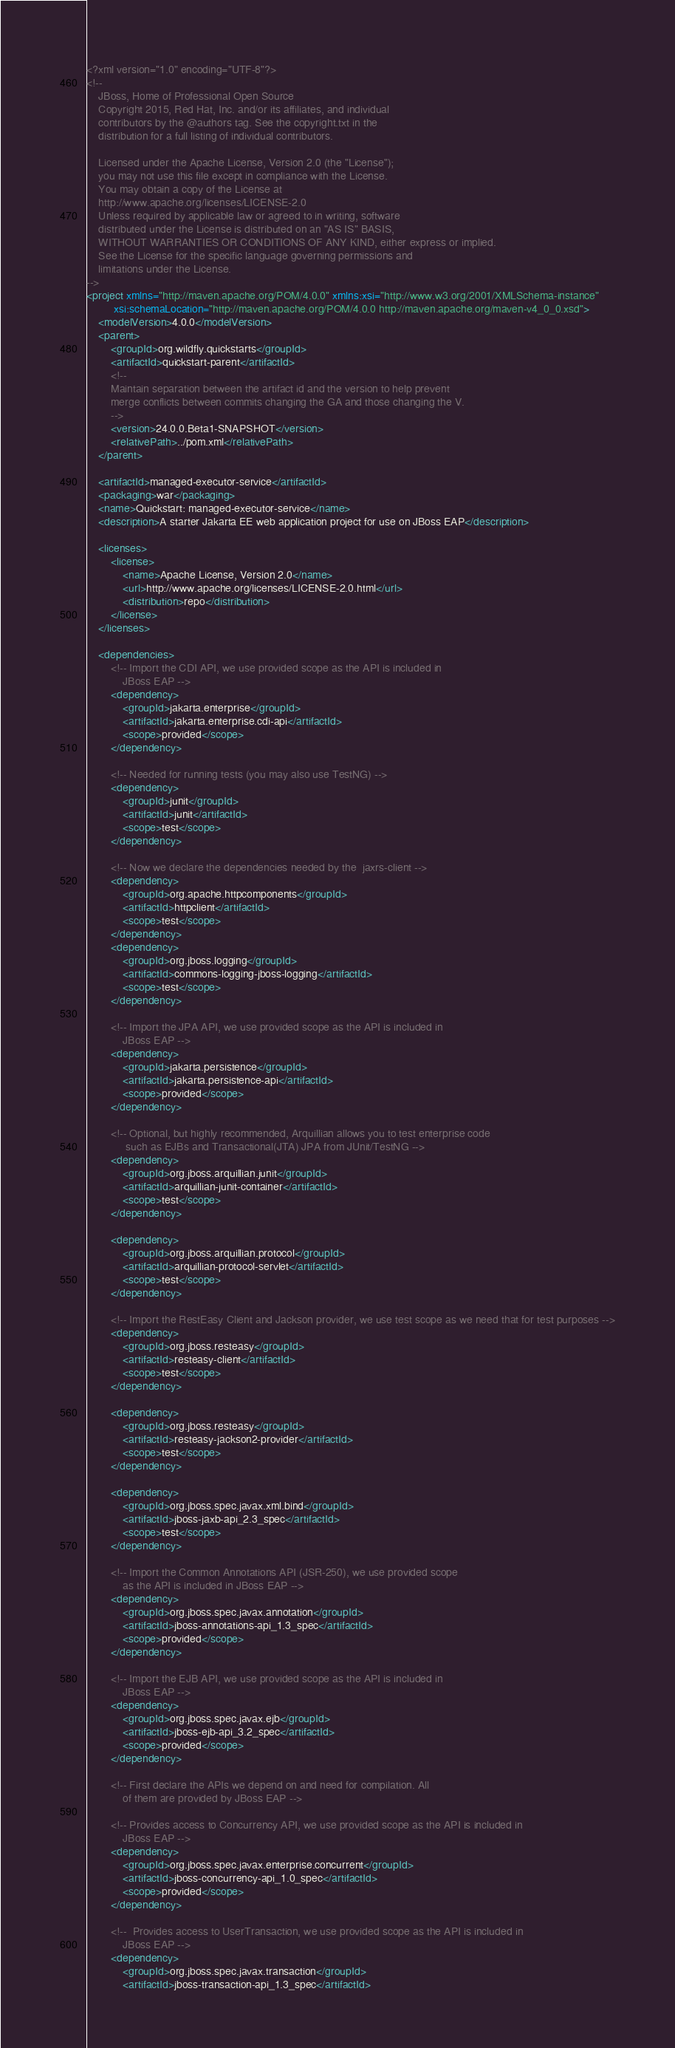<code> <loc_0><loc_0><loc_500><loc_500><_XML_><?xml version="1.0" encoding="UTF-8"?>
<!--
    JBoss, Home of Professional Open Source
    Copyright 2015, Red Hat, Inc. and/or its affiliates, and individual
    contributors by the @authors tag. See the copyright.txt in the
    distribution for a full listing of individual contributors.

    Licensed under the Apache License, Version 2.0 (the "License");
    you may not use this file except in compliance with the License.
    You may obtain a copy of the License at
    http://www.apache.org/licenses/LICENSE-2.0
    Unless required by applicable law or agreed to in writing, software
    distributed under the License is distributed on an "AS IS" BASIS,
    WITHOUT WARRANTIES OR CONDITIONS OF ANY KIND, either express or implied.
    See the License for the specific language governing permissions and
    limitations under the License.
-->
<project xmlns="http://maven.apache.org/POM/4.0.0" xmlns:xsi="http://www.w3.org/2001/XMLSchema-instance"
         xsi:schemaLocation="http://maven.apache.org/POM/4.0.0 http://maven.apache.org/maven-v4_0_0.xsd">
    <modelVersion>4.0.0</modelVersion>
    <parent>
        <groupId>org.wildfly.quickstarts</groupId>
        <artifactId>quickstart-parent</artifactId>
        <!--
        Maintain separation between the artifact id and the version to help prevent
        merge conflicts between commits changing the GA and those changing the V.
        -->
        <version>24.0.0.Beta1-SNAPSHOT</version>
        <relativePath>../pom.xml</relativePath>
    </parent>

    <artifactId>managed-executor-service</artifactId>
    <packaging>war</packaging>
    <name>Quickstart: managed-executor-service</name>
    <description>A starter Jakarta EE web application project for use on JBoss EAP</description>

    <licenses>
        <license>
            <name>Apache License, Version 2.0</name>
            <url>http://www.apache.org/licenses/LICENSE-2.0.html</url>
            <distribution>repo</distribution>
        </license>
    </licenses>

    <dependencies>
        <!-- Import the CDI API, we use provided scope as the API is included in
            JBoss EAP -->
        <dependency>
            <groupId>jakarta.enterprise</groupId>
            <artifactId>jakarta.enterprise.cdi-api</artifactId>
            <scope>provided</scope>
        </dependency>

        <!-- Needed for running tests (you may also use TestNG) -->
        <dependency>
            <groupId>junit</groupId>
            <artifactId>junit</artifactId>
            <scope>test</scope>
        </dependency>

        <!-- Now we declare the dependencies needed by the  jaxrs-client -->
        <dependency>
            <groupId>org.apache.httpcomponents</groupId>
            <artifactId>httpclient</artifactId>
            <scope>test</scope>
        </dependency>
        <dependency>
            <groupId>org.jboss.logging</groupId>
            <artifactId>commons-logging-jboss-logging</artifactId>
            <scope>test</scope>
        </dependency>

        <!-- Import the JPA API, we use provided scope as the API is included in
            JBoss EAP -->
        <dependency>
            <groupId>jakarta.persistence</groupId>
            <artifactId>jakarta.persistence-api</artifactId>
            <scope>provided</scope>
        </dependency>

        <!-- Optional, but highly recommended, Arquillian allows you to test enterprise code 
             such as EJBs and Transactional(JTA) JPA from JUnit/TestNG -->
        <dependency>
            <groupId>org.jboss.arquillian.junit</groupId>
            <artifactId>arquillian-junit-container</artifactId>
            <scope>test</scope>
        </dependency>

        <dependency>
            <groupId>org.jboss.arquillian.protocol</groupId>
            <artifactId>arquillian-protocol-servlet</artifactId>
            <scope>test</scope>
        </dependency>

        <!-- Import the RestEasy Client and Jackson provider, we use test scope as we need that for test purposes -->
        <dependency>
            <groupId>org.jboss.resteasy</groupId>
            <artifactId>resteasy-client</artifactId>
            <scope>test</scope>
        </dependency>

        <dependency>
            <groupId>org.jboss.resteasy</groupId>
            <artifactId>resteasy-jackson2-provider</artifactId>
            <scope>test</scope>
        </dependency>

        <dependency>
            <groupId>org.jboss.spec.javax.xml.bind</groupId>
            <artifactId>jboss-jaxb-api_2.3_spec</artifactId>
            <scope>test</scope>
        </dependency>

        <!-- Import the Common Annotations API (JSR-250), we use provided scope
            as the API is included in JBoss EAP -->
        <dependency>
            <groupId>org.jboss.spec.javax.annotation</groupId>
            <artifactId>jboss-annotations-api_1.3_spec</artifactId>
            <scope>provided</scope>
        </dependency>

        <!-- Import the EJB API, we use provided scope as the API is included in
            JBoss EAP -->
        <dependency>
            <groupId>org.jboss.spec.javax.ejb</groupId>
            <artifactId>jboss-ejb-api_3.2_spec</artifactId>
            <scope>provided</scope>
        </dependency>

        <!-- First declare the APIs we depend on and need for compilation. All
            of them are provided by JBoss EAP -->

        <!-- Provides access to Concurrency API, we use provided scope as the API is included in
            JBoss EAP -->
        <dependency>
            <groupId>org.jboss.spec.javax.enterprise.concurrent</groupId>
            <artifactId>jboss-concurrency-api_1.0_spec</artifactId>
            <scope>provided</scope>
        </dependency>

        <!--  Provides access to UserTransaction, we use provided scope as the API is included in
            JBoss EAP -->
        <dependency>
            <groupId>org.jboss.spec.javax.transaction</groupId>
            <artifactId>jboss-transaction-api_1.3_spec</artifactId></code> 